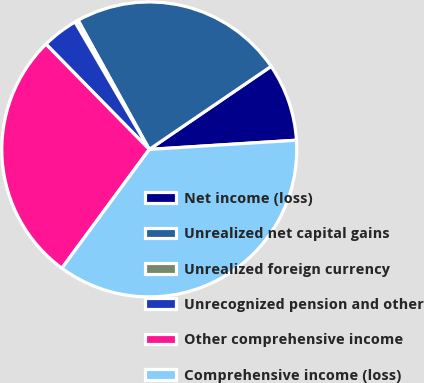Convert chart. <chart><loc_0><loc_0><loc_500><loc_500><pie_chart><fcel>Net income (loss)<fcel>Unrealized net capital gains<fcel>Unrealized foreign currency<fcel>Unrecognized pension and other<fcel>Other comprehensive income<fcel>Comprehensive income (loss)<nl><fcel>8.53%<fcel>23.5%<fcel>0.38%<fcel>3.95%<fcel>27.56%<fcel>36.09%<nl></chart> 